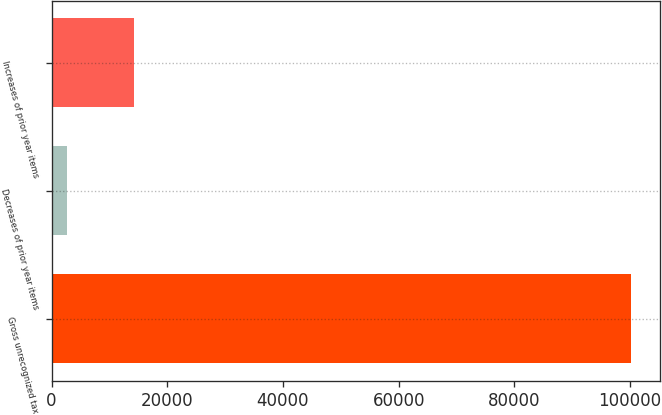Convert chart to OTSL. <chart><loc_0><loc_0><loc_500><loc_500><bar_chart><fcel>Gross unrecognized tax<fcel>Decreases of prior year items<fcel>Increases of prior year items<nl><fcel>100168<fcel>2605<fcel>14213<nl></chart> 